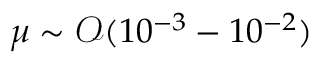Convert formula to latex. <formula><loc_0><loc_0><loc_500><loc_500>\mu \sim \mathcal { O } ( 1 0 ^ { - 3 } - 1 0 ^ { - 2 } )</formula> 